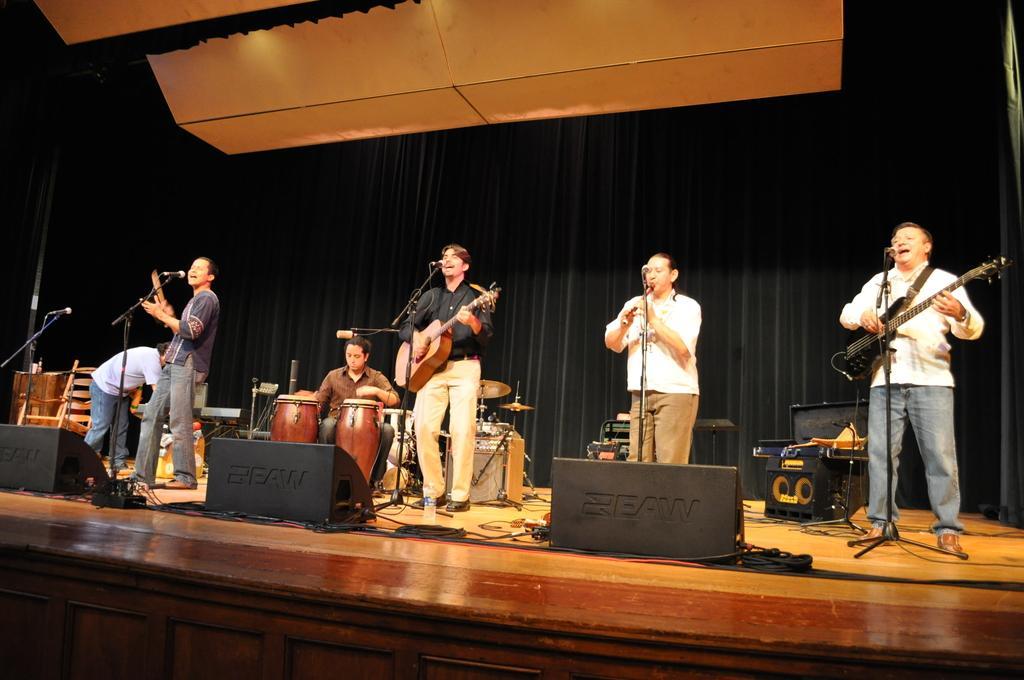Describe this image in one or two sentences. This picture describes about group of people and they are musicians and they are playing a musical instrument in front of microphone, in the middle of the image a person is seated on the chair and playing drums, in the background we can see curtains and musical instruments. 